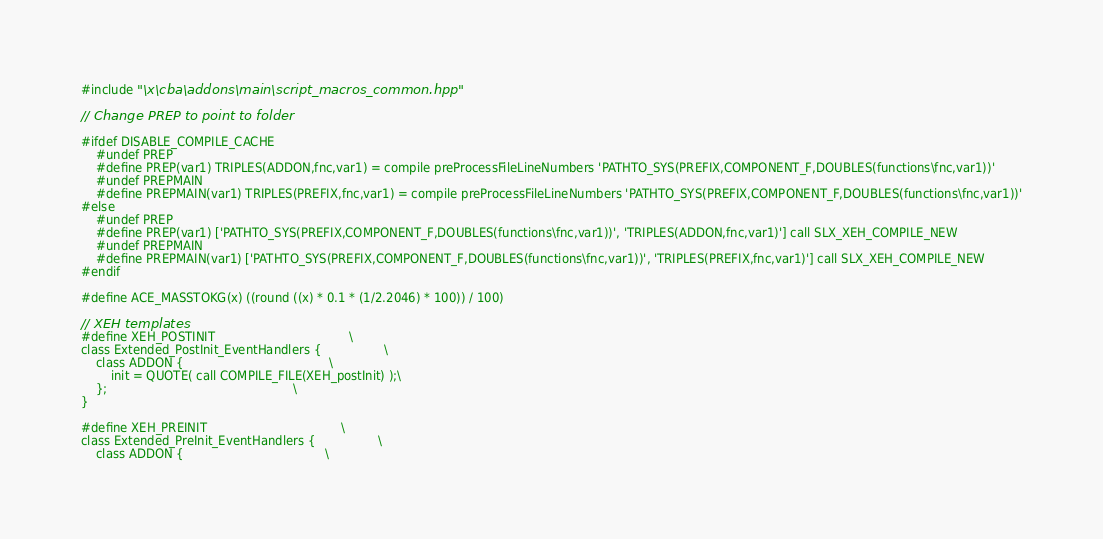Convert code to text. <code><loc_0><loc_0><loc_500><loc_500><_C++_>#include "\x\cba\addons\main\script_macros_common.hpp"

// Change PREP to point to folder

#ifdef DISABLE_COMPILE_CACHE
    #undef PREP
    #define PREP(var1) TRIPLES(ADDON,fnc,var1) = compile preProcessFileLineNumbers 'PATHTO_SYS(PREFIX,COMPONENT_F,DOUBLES(functions\fnc,var1))'
    #undef PREPMAIN
    #define PREPMAIN(var1) TRIPLES(PREFIX,fnc,var1) = compile preProcessFileLineNumbers 'PATHTO_SYS(PREFIX,COMPONENT_F,DOUBLES(functions\fnc,var1))'
#else
    #undef PREP
    #define PREP(var1) ['PATHTO_SYS(PREFIX,COMPONENT_F,DOUBLES(functions\fnc,var1))', 'TRIPLES(ADDON,fnc,var1)'] call SLX_XEH_COMPILE_NEW
    #undef PREPMAIN
    #define PREPMAIN(var1) ['PATHTO_SYS(PREFIX,COMPONENT_F,DOUBLES(functions\fnc,var1))', 'TRIPLES(PREFIX,fnc,var1)'] call SLX_XEH_COMPILE_NEW
#endif

#define ACE_MASSTOKG(x) ((round ((x) * 0.1 * (1/2.2046) * 100)) / 100)

// XEH templates
#define XEH_POSTINIT                                    \
class Extended_PostInit_EventHandlers {                 \
    class ADDON {                                       \
        init = QUOTE( call COMPILE_FILE(XEH_postInit) );\
    };                                                  \
}

#define XEH_PREINIT                                    \
class Extended_PreInit_EventHandlers {                 \
    class ADDON {                                      \</code> 